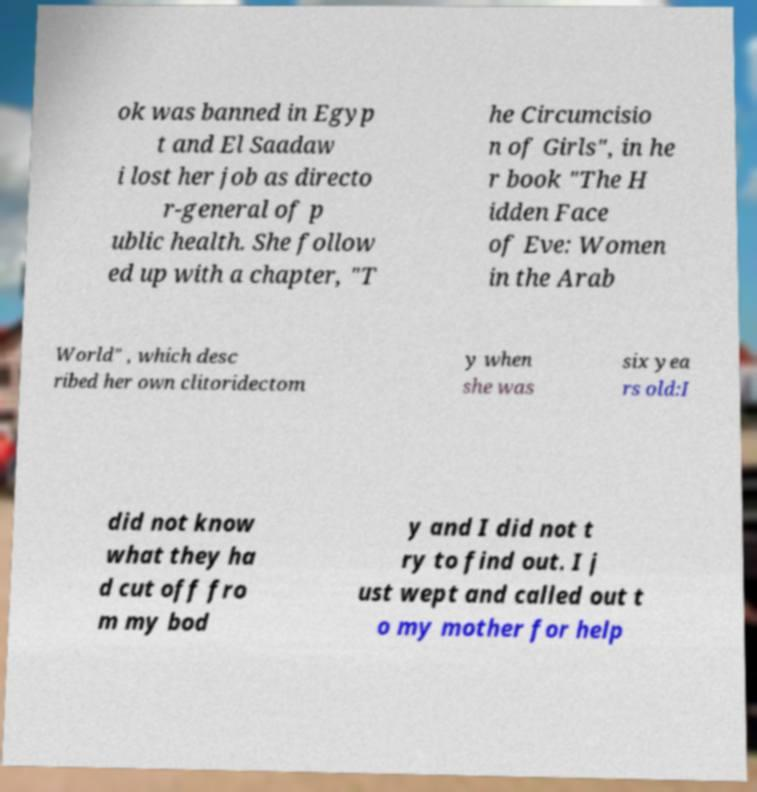Can you accurately transcribe the text from the provided image for me? ok was banned in Egyp t and El Saadaw i lost her job as directo r-general of p ublic health. She follow ed up with a chapter, "T he Circumcisio n of Girls", in he r book "The H idden Face of Eve: Women in the Arab World" , which desc ribed her own clitoridectom y when she was six yea rs old:I did not know what they ha d cut off fro m my bod y and I did not t ry to find out. I j ust wept and called out t o my mother for help 